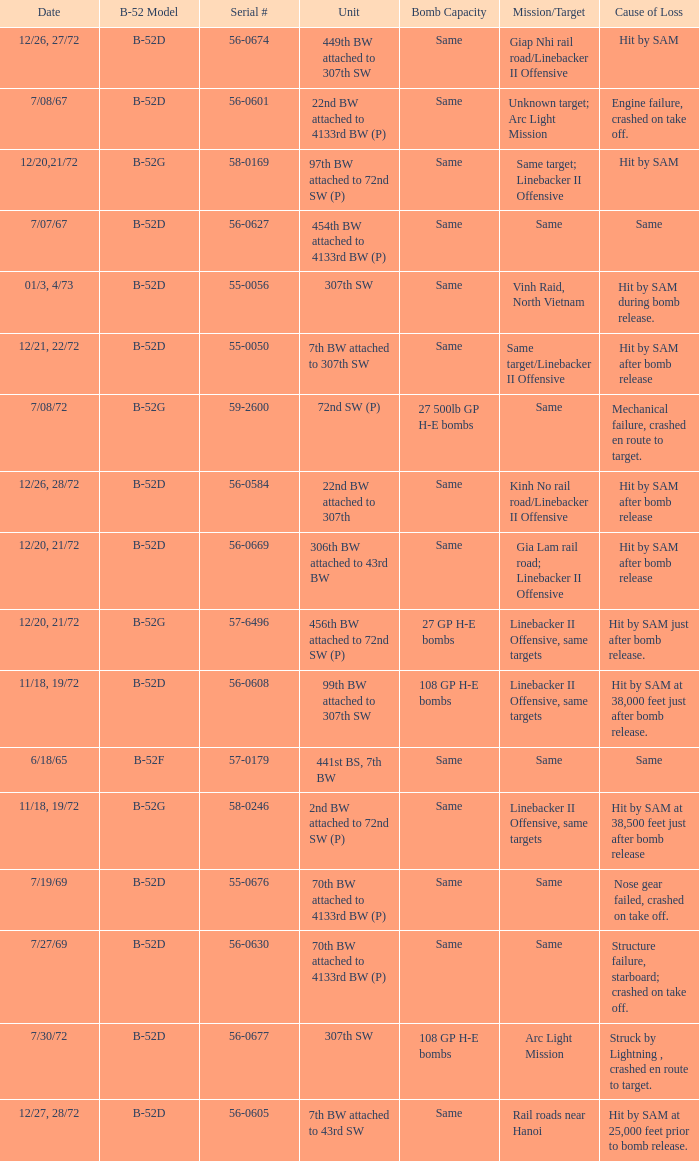When  27 gp h-e bombs the capacity of the bomb what is the cause of loss? Hit by SAM just after bomb release. 